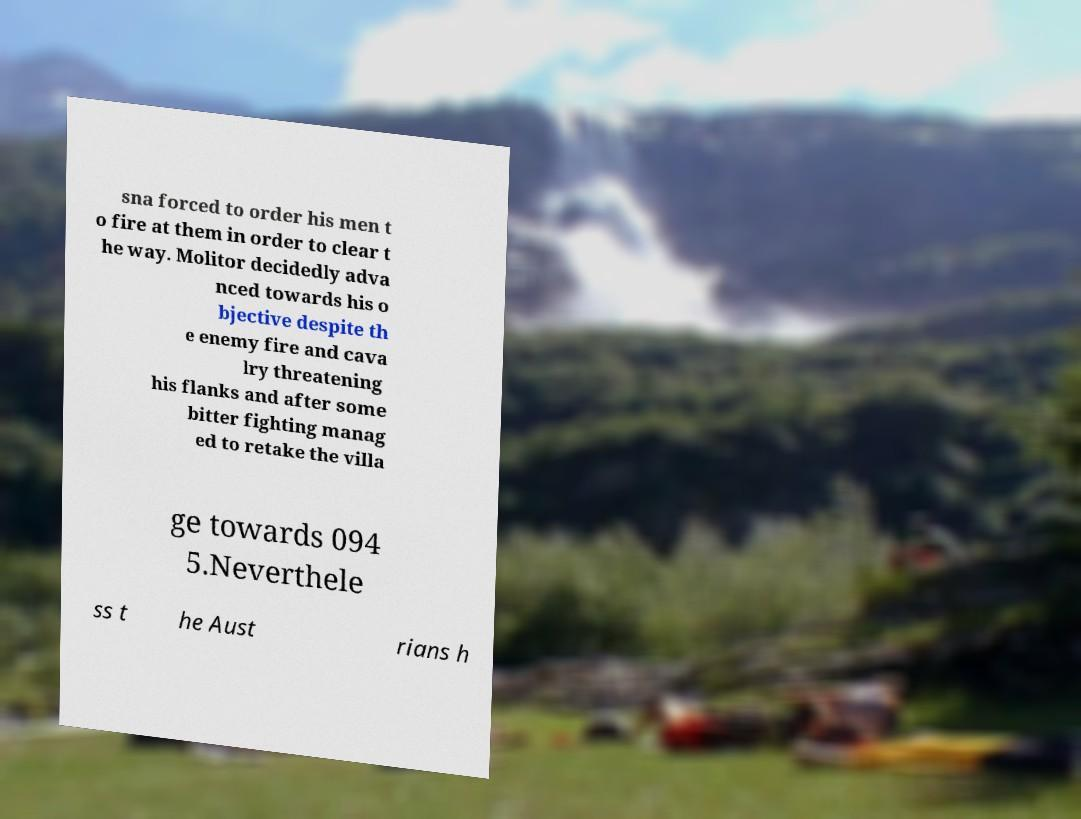Could you assist in decoding the text presented in this image and type it out clearly? sna forced to order his men t o fire at them in order to clear t he way. Molitor decidedly adva nced towards his o bjective despite th e enemy fire and cava lry threatening his flanks and after some bitter fighting manag ed to retake the villa ge towards 094 5.Neverthele ss t he Aust rians h 